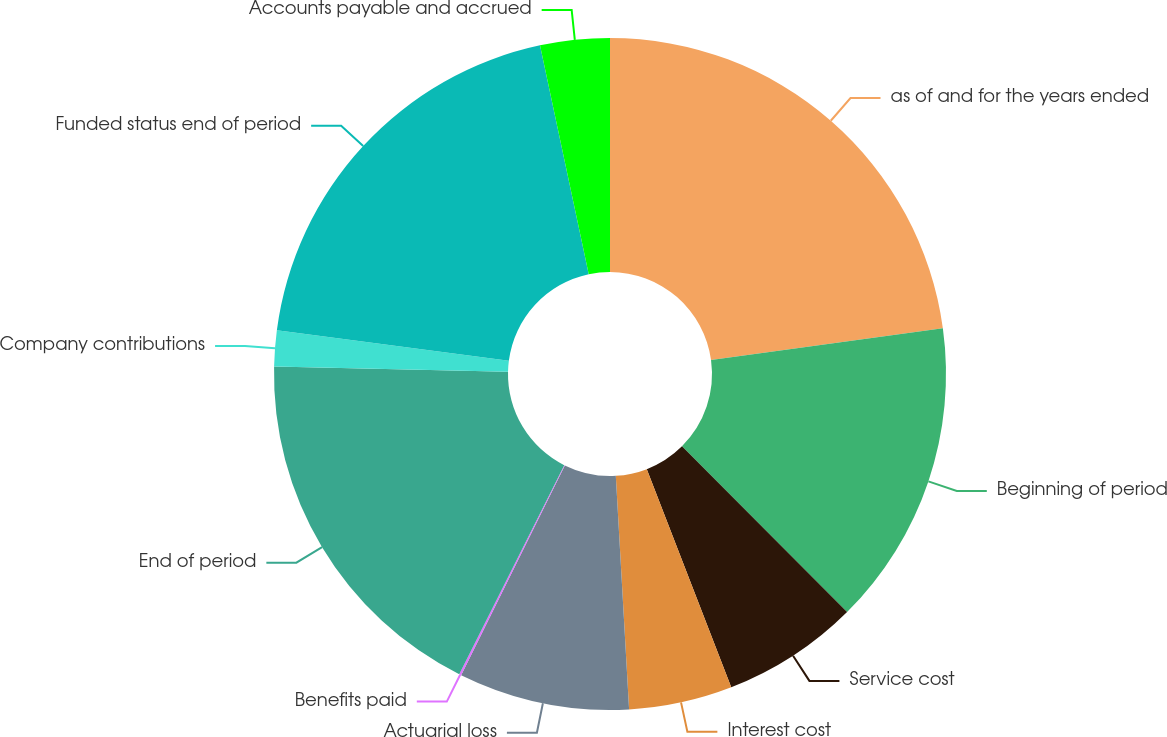<chart> <loc_0><loc_0><loc_500><loc_500><pie_chart><fcel>as of and for the years ended<fcel>Beginning of period<fcel>Service cost<fcel>Interest cost<fcel>Actuarial loss<fcel>Benefits paid<fcel>End of period<fcel>Company contributions<fcel>Funded status end of period<fcel>Accounts payable and accrued<nl><fcel>22.82%<fcel>14.71%<fcel>6.59%<fcel>4.97%<fcel>8.21%<fcel>0.1%<fcel>17.95%<fcel>1.72%<fcel>19.58%<fcel>3.34%<nl></chart> 